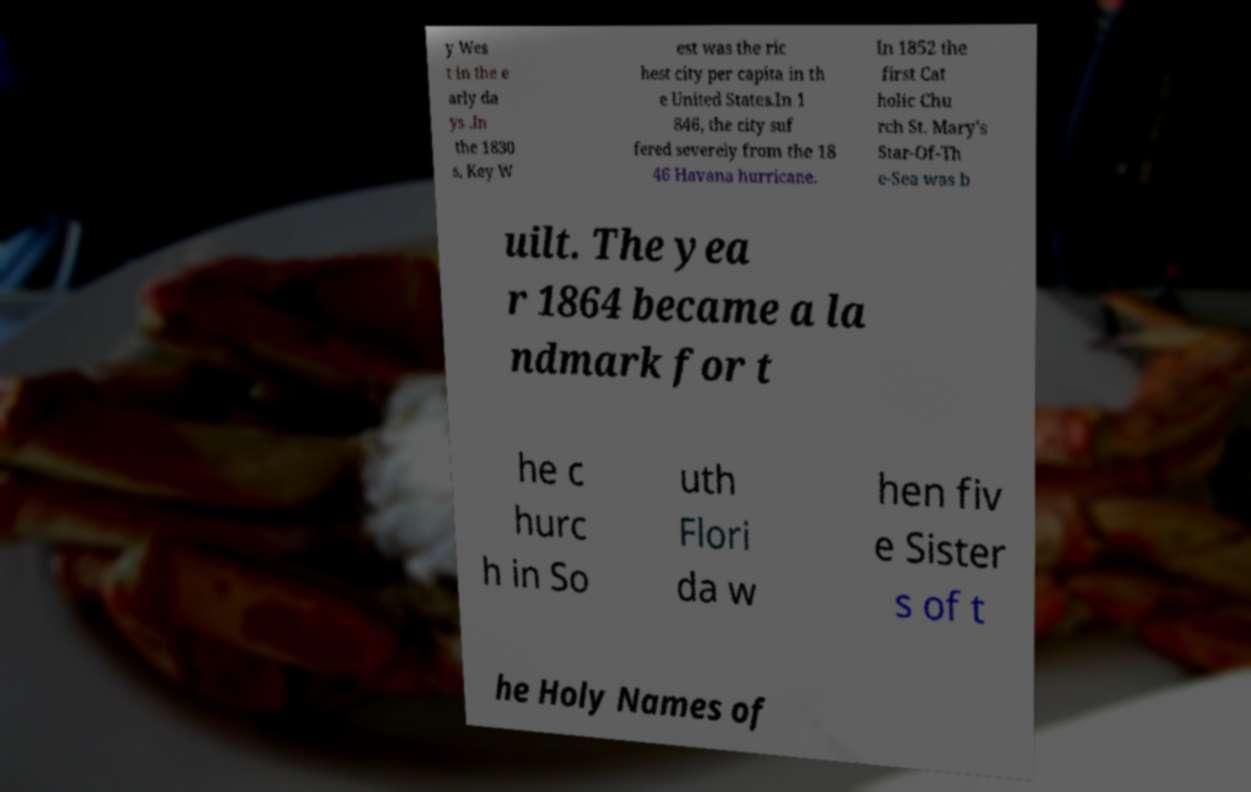What messages or text are displayed in this image? I need them in a readable, typed format. y Wes t in the e arly da ys .In the 1830 s, Key W est was the ric hest city per capita in th e United States.In 1 846, the city suf fered severely from the 18 46 Havana hurricane. In 1852 the first Cat holic Chu rch St. Mary's Star-Of-Th e-Sea was b uilt. The yea r 1864 became a la ndmark for t he c hurc h in So uth Flori da w hen fiv e Sister s of t he Holy Names of 